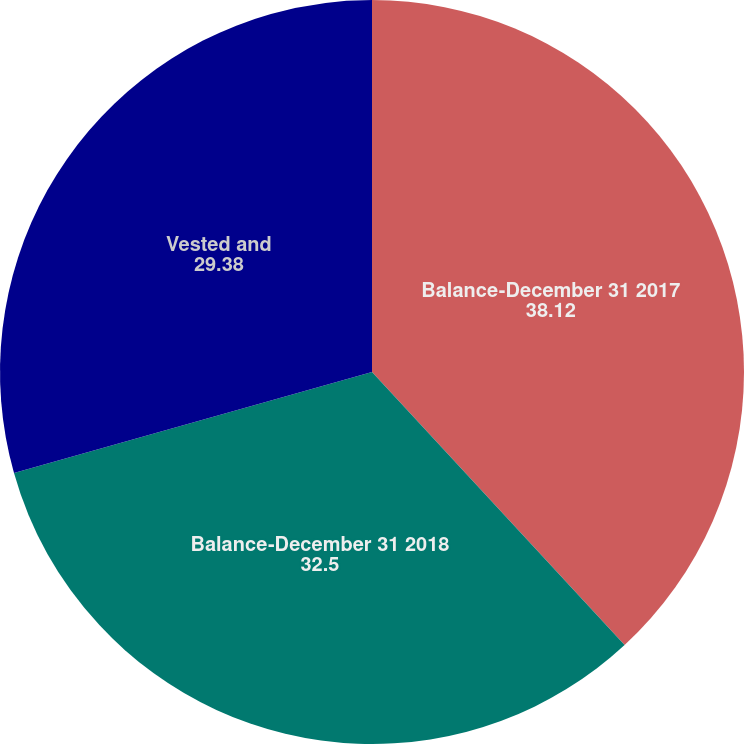Convert chart to OTSL. <chart><loc_0><loc_0><loc_500><loc_500><pie_chart><fcel>Balance-December 31 2017<fcel>Balance-December 31 2018<fcel>Vested and<nl><fcel>38.12%<fcel>32.5%<fcel>29.38%<nl></chart> 